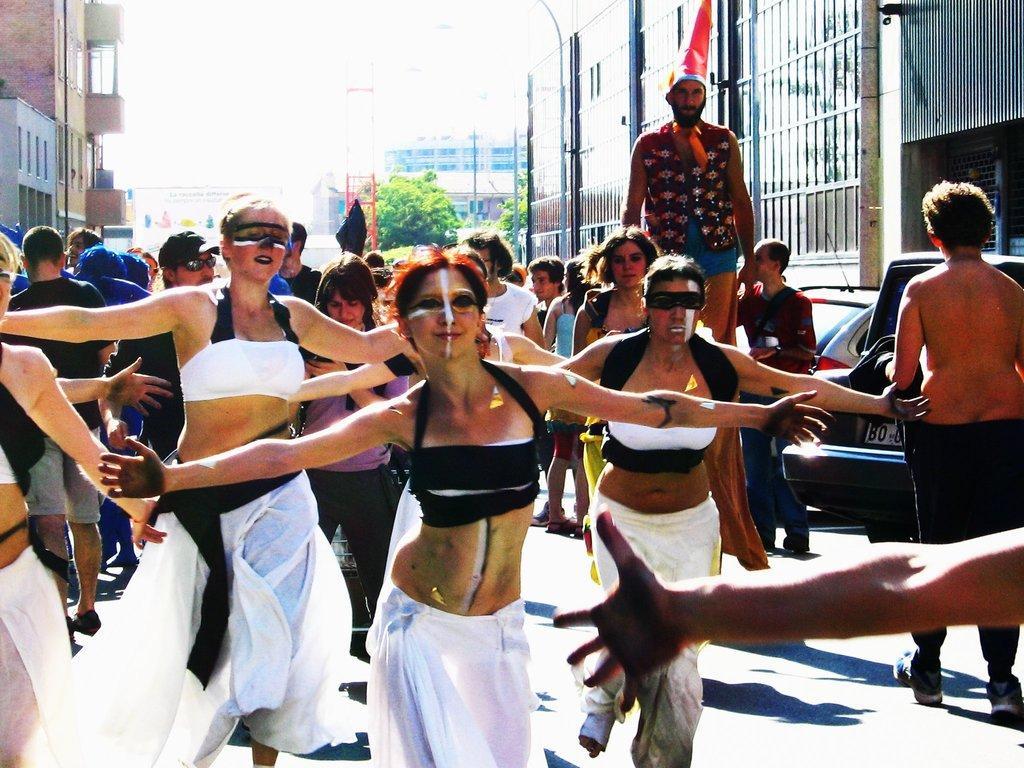Could you give a brief overview of what you see in this image? In the picture I can see a group of people are standing on the ground. In the background I can see trees, buildings, poles and some other objects. On the right side I can see a vehicle on the road. 